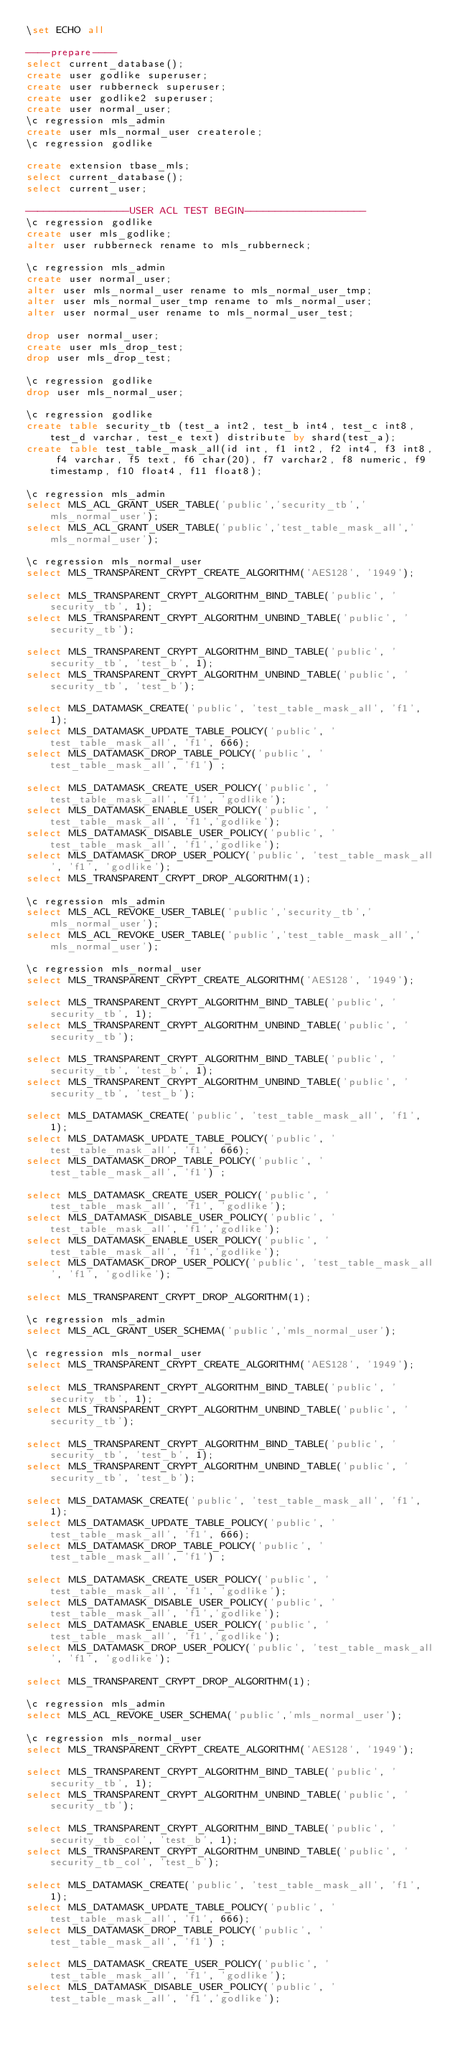<code> <loc_0><loc_0><loc_500><loc_500><_SQL_>\set ECHO all

----prepare----
select current_database();
create user godlike superuser;
create user rubberneck superuser;
create user godlike2 superuser;
create user normal_user;
\c regression mls_admin
create user mls_normal_user createrole;
\c regression godlike

create extension tbase_mls;
select current_database();
select current_user;

-----------------USER ACL TEST BEGIN--------------------
\c regression godlike
create user mls_godlike;
alter user rubberneck rename to mls_rubberneck;

\c regression mls_admin
create user normal_user;
alter user mls_normal_user rename to mls_normal_user_tmp;
alter user mls_normal_user_tmp rename to mls_normal_user;
alter user normal_user rename to mls_normal_user_test;

drop user normal_user;
create user mls_drop_test;
drop user mls_drop_test;

\c regression godlike
drop user mls_normal_user;

\c regression godlike
create table security_tb (test_a int2, test_b int4, test_c int8, test_d varchar, test_e text) distribute by shard(test_a);
create table test_table_mask_all(id int, f1 int2, f2 int4, f3 int8, f4 varchar, f5 text, f6 char(20), f7 varchar2, f8 numeric, f9 timestamp, f10 float4, f11 float8);

\c regression mls_admin
select MLS_ACL_GRANT_USER_TABLE('public','security_tb','mls_normal_user');
select MLS_ACL_GRANT_USER_TABLE('public','test_table_mask_all','mls_normal_user');

\c regression mls_normal_user
select MLS_TRANSPARENT_CRYPT_CREATE_ALGORITHM('AES128', '1949');

select MLS_TRANSPARENT_CRYPT_ALGORITHM_BIND_TABLE('public', 'security_tb', 1);  
select MLS_TRANSPARENT_CRYPT_ALGORITHM_UNBIND_TABLE('public', 'security_tb');  

select MLS_TRANSPARENT_CRYPT_ALGORITHM_BIND_TABLE('public', 'security_tb', 'test_b', 1);
select MLS_TRANSPARENT_CRYPT_ALGORITHM_UNBIND_TABLE('public', 'security_tb', 'test_b');

select MLS_DATAMASK_CREATE('public', 'test_table_mask_all', 'f1', 1);
select MLS_DATAMASK_UPDATE_TABLE_POLICY('public', 'test_table_mask_all', 'f1', 666);
select MLS_DATAMASK_DROP_TABLE_POLICY('public', 'test_table_mask_all', 'f1') ; 

select MLS_DATAMASK_CREATE_USER_POLICY('public', 'test_table_mask_all', 'f1', 'godlike');
select MLS_DATAMASK_ENABLE_USER_POLICY('public', 'test_table_mask_all', 'f1','godlike');
select MLS_DATAMASK_DISABLE_USER_POLICY('public', 'test_table_mask_all', 'f1','godlike');
select MLS_DATAMASK_DROP_USER_POLICY('public', 'test_table_mask_all', 'f1', 'godlike');
select MLS_TRANSPARENT_CRYPT_DROP_ALGORITHM(1);

\c regression mls_admin
select MLS_ACL_REVOKE_USER_TABLE('public','security_tb','mls_normal_user');
select MLS_ACL_REVOKE_USER_TABLE('public','test_table_mask_all','mls_normal_user');

\c regression mls_normal_user
select MLS_TRANSPARENT_CRYPT_CREATE_ALGORITHM('AES128', '1949');

select MLS_TRANSPARENT_CRYPT_ALGORITHM_BIND_TABLE('public', 'security_tb', 1);  
select MLS_TRANSPARENT_CRYPT_ALGORITHM_UNBIND_TABLE('public', 'security_tb');  

select MLS_TRANSPARENT_CRYPT_ALGORITHM_BIND_TABLE('public', 'security_tb', 'test_b', 1);
select MLS_TRANSPARENT_CRYPT_ALGORITHM_UNBIND_TABLE('public', 'security_tb', 'test_b');

select MLS_DATAMASK_CREATE('public', 'test_table_mask_all', 'f1', 1);
select MLS_DATAMASK_UPDATE_TABLE_POLICY('public', 'test_table_mask_all', 'f1', 666);
select MLS_DATAMASK_DROP_TABLE_POLICY('public', 'test_table_mask_all', 'f1') ; 

select MLS_DATAMASK_CREATE_USER_POLICY('public', 'test_table_mask_all', 'f1', 'godlike');
select MLS_DATAMASK_DISABLE_USER_POLICY('public', 'test_table_mask_all', 'f1','godlike');
select MLS_DATAMASK_ENABLE_USER_POLICY('public', 'test_table_mask_all', 'f1','godlike');
select MLS_DATAMASK_DROP_USER_POLICY('public', 'test_table_mask_all', 'f1', 'godlike');

select MLS_TRANSPARENT_CRYPT_DROP_ALGORITHM(1);

\c regression mls_admin
select MLS_ACL_GRANT_USER_SCHEMA('public','mls_normal_user');

\c regression mls_normal_user
select MLS_TRANSPARENT_CRYPT_CREATE_ALGORITHM('AES128', '1949');

select MLS_TRANSPARENT_CRYPT_ALGORITHM_BIND_TABLE('public', 'security_tb', 1);  
select MLS_TRANSPARENT_CRYPT_ALGORITHM_UNBIND_TABLE('public', 'security_tb');  

select MLS_TRANSPARENT_CRYPT_ALGORITHM_BIND_TABLE('public', 'security_tb', 'test_b', 1);
select MLS_TRANSPARENT_CRYPT_ALGORITHM_UNBIND_TABLE('public', 'security_tb', 'test_b');

select MLS_DATAMASK_CREATE('public', 'test_table_mask_all', 'f1', 1);
select MLS_DATAMASK_UPDATE_TABLE_POLICY('public', 'test_table_mask_all', 'f1', 666);
select MLS_DATAMASK_DROP_TABLE_POLICY('public', 'test_table_mask_all', 'f1') ; 

select MLS_DATAMASK_CREATE_USER_POLICY('public', 'test_table_mask_all', 'f1', 'godlike');
select MLS_DATAMASK_DISABLE_USER_POLICY('public', 'test_table_mask_all', 'f1','godlike');
select MLS_DATAMASK_ENABLE_USER_POLICY('public', 'test_table_mask_all', 'f1','godlike');
select MLS_DATAMASK_DROP_USER_POLICY('public', 'test_table_mask_all', 'f1', 'godlike');

select MLS_TRANSPARENT_CRYPT_DROP_ALGORITHM(1);

\c regression mls_admin
select MLS_ACL_REVOKE_USER_SCHEMA('public','mls_normal_user');

\c regression mls_normal_user
select MLS_TRANSPARENT_CRYPT_CREATE_ALGORITHM('AES128', '1949');

select MLS_TRANSPARENT_CRYPT_ALGORITHM_BIND_TABLE('public', 'security_tb', 1);  
select MLS_TRANSPARENT_CRYPT_ALGORITHM_UNBIND_TABLE('public', 'security_tb');  

select MLS_TRANSPARENT_CRYPT_ALGORITHM_BIND_TABLE('public', 'security_tb_col', 'test_b', 1);   
select MLS_TRANSPARENT_CRYPT_ALGORITHM_UNBIND_TABLE('public', 'security_tb_col', 'test_b');     

select MLS_DATAMASK_CREATE('public', 'test_table_mask_all', 'f1', 1);
select MLS_DATAMASK_UPDATE_TABLE_POLICY('public', 'test_table_mask_all', 'f1', 666);
select MLS_DATAMASK_DROP_TABLE_POLICY('public', 'test_table_mask_all', 'f1') ; 

select MLS_DATAMASK_CREATE_USER_POLICY('public', 'test_table_mask_all', 'f1', 'godlike');
select MLS_DATAMASK_DISABLE_USER_POLICY('public', 'test_table_mask_all', 'f1','godlike');</code> 